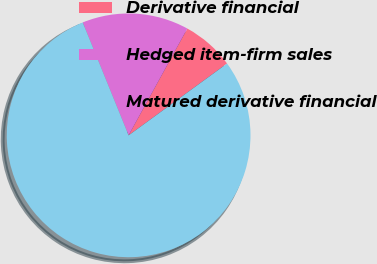<chart> <loc_0><loc_0><loc_500><loc_500><pie_chart><fcel>Derivative financial<fcel>Hedged item-firm sales<fcel>Matured derivative financial<nl><fcel>6.96%<fcel>14.15%<fcel>78.89%<nl></chart> 